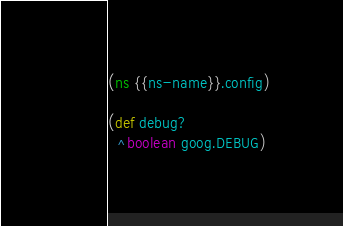Convert code to text. <code><loc_0><loc_0><loc_500><loc_500><_Clojure_>(ns {{ns-name}}.config)

(def debug?
  ^boolean goog.DEBUG)
</code> 